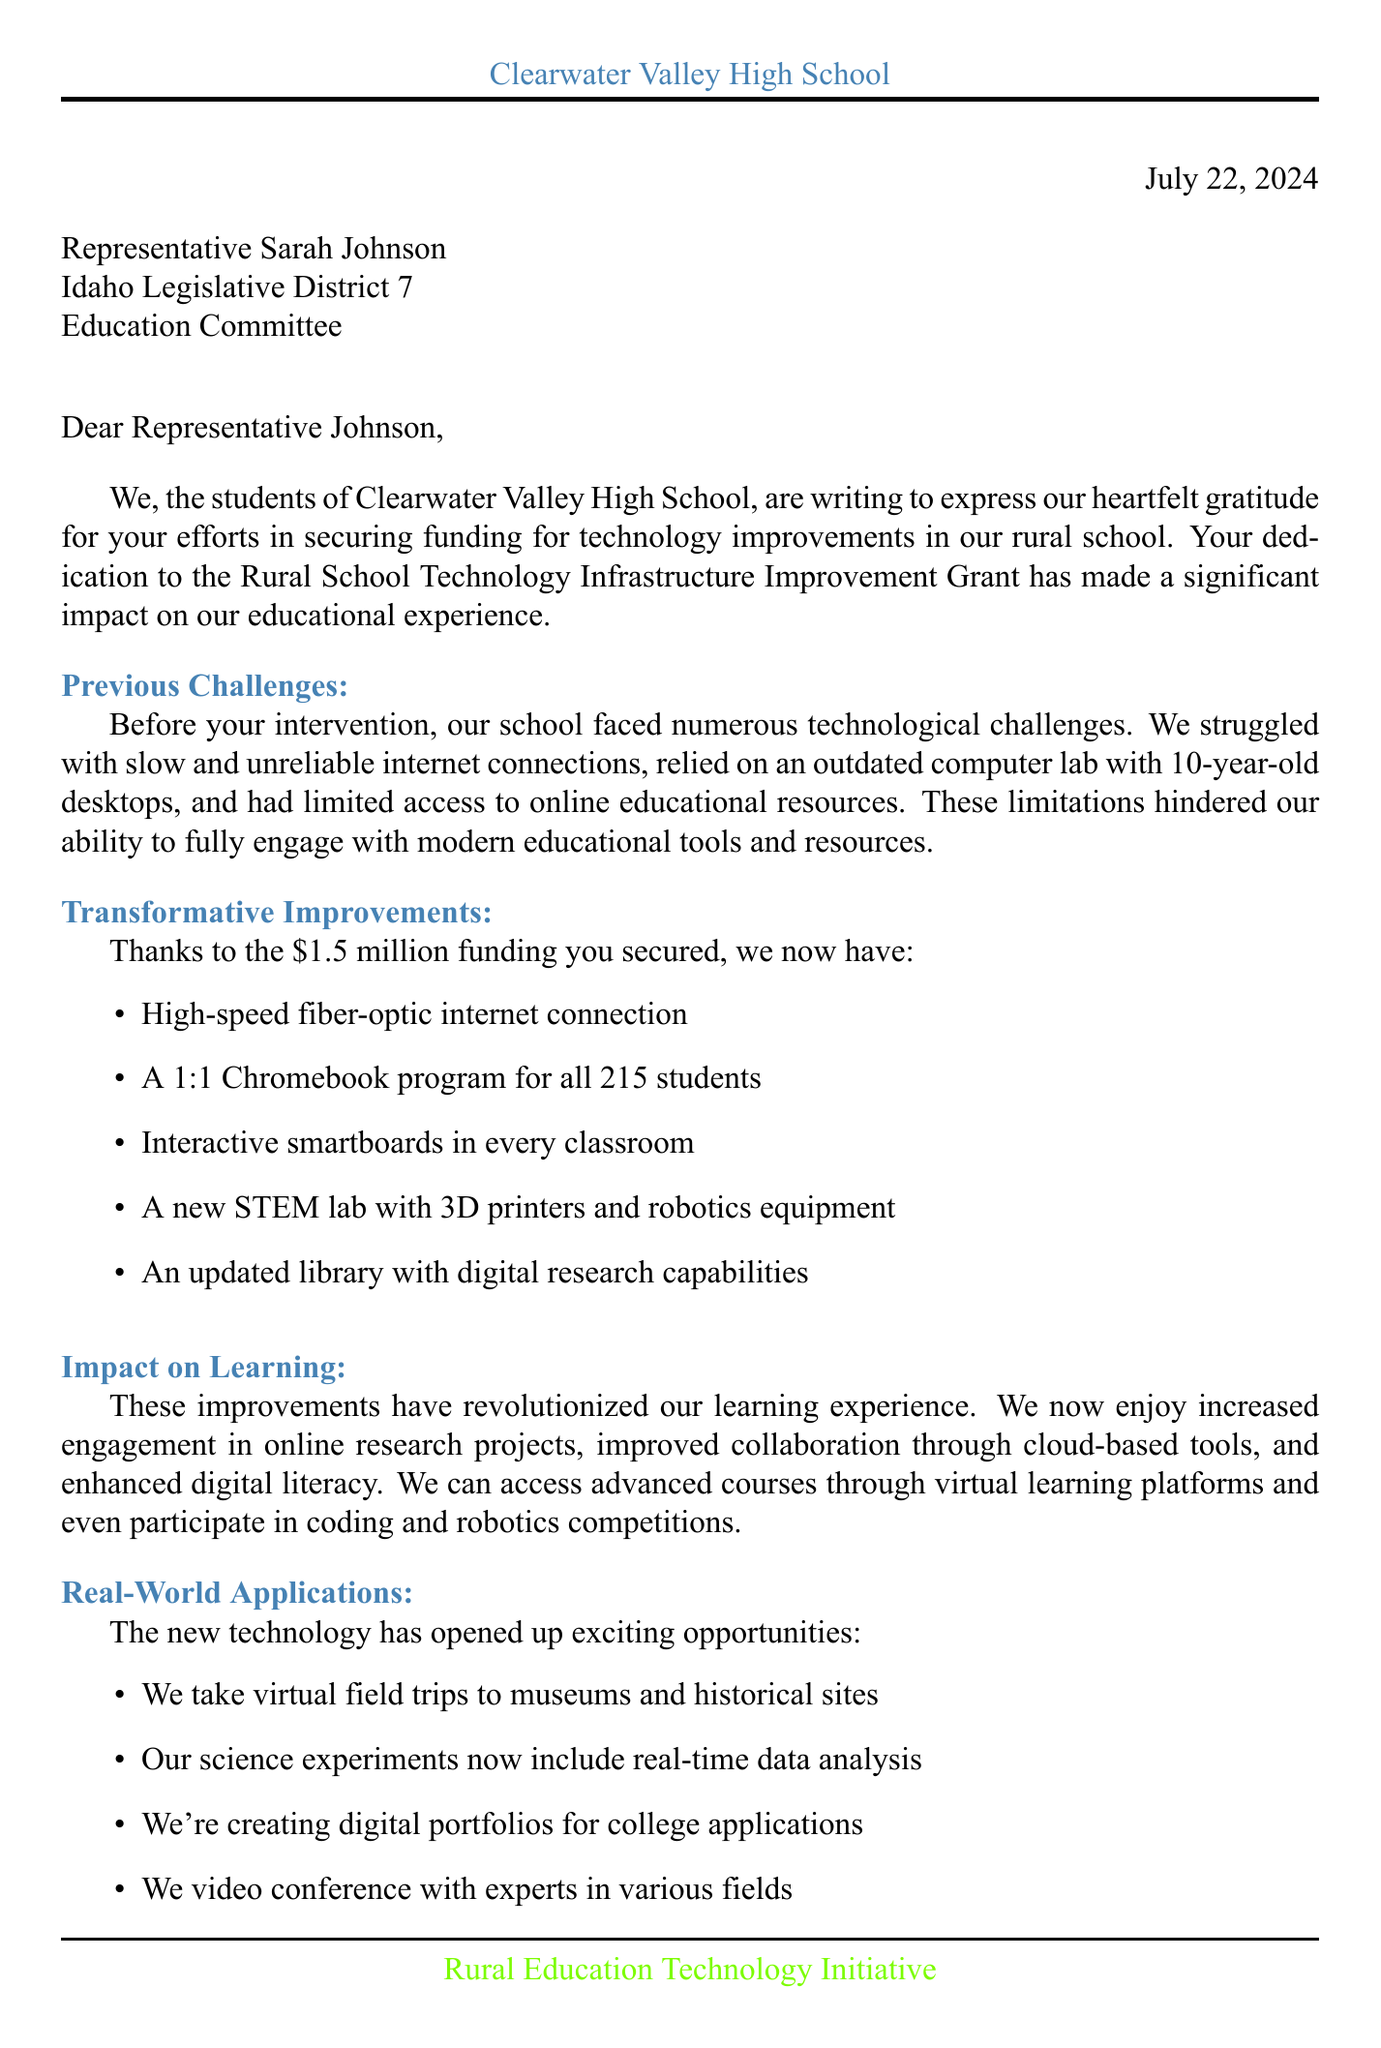What is the name of the school? The name of the school is mentioned in the opening paragraph of the letter.
Answer: Clearwater Valley High School Who is the legislator addressed in the letter? The letter addresses a specific legislator whose name is included in the greeting.
Answer: Representative Sarah Johnson What amount of funding was secured for technology improvements? The funding amount is specified in the body of the letter, highlighting its significance.
Answer: $1.5 million What major technology improvement is mentioned first? The first technology improvement listed emphasizes the critical need for better connectivity in the school.
Answer: High-speed fiber-optic internet connection What is one example of how new technology is being used? The letter lists specific examples of new technology applications in the school, showcasing its impact on learning.
Answer: Virtual field trips to museums and historical sites What is one future aspiration mentioned by the students? The aspirations demonstrate the goals of the students enabled by the new technology.
Answer: Pursuing careers in technology and engineering How many students are enrolled at Clearwater Valley High School? The number of students is indicated under school details in the document.
Answer: 215 What type of committee is Representative Sarah Johnson part of? The committee affiliation is stated to show the legislator’s role in education.
Answer: Education Committee What is the location of Clearwater Valley High School? The location is mentioned alongside the school's name in the closing section of the letter.
Answer: Kooskia, Idaho 